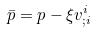Convert formula to latex. <formula><loc_0><loc_0><loc_500><loc_500>\bar { p } = p - \xi v ^ { i } _ { ; i }</formula> 